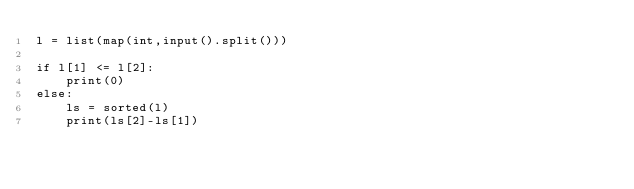Convert code to text. <code><loc_0><loc_0><loc_500><loc_500><_Python_>l = list(map(int,input().split()))

if l[1] <= l[2]:
    print(0)
else:
    ls = sorted(l)
    print(ls[2]-ls[1])</code> 